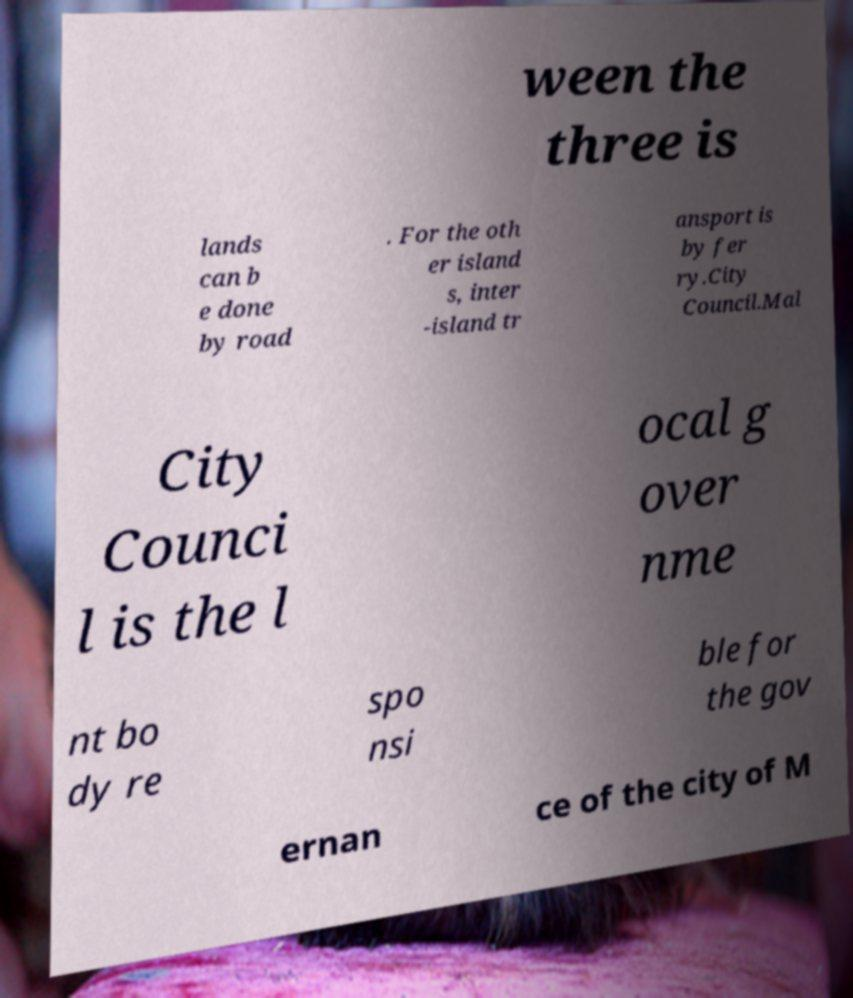Could you extract and type out the text from this image? ween the three is lands can b e done by road . For the oth er island s, inter -island tr ansport is by fer ry.City Council.Mal City Counci l is the l ocal g over nme nt bo dy re spo nsi ble for the gov ernan ce of the city of M 